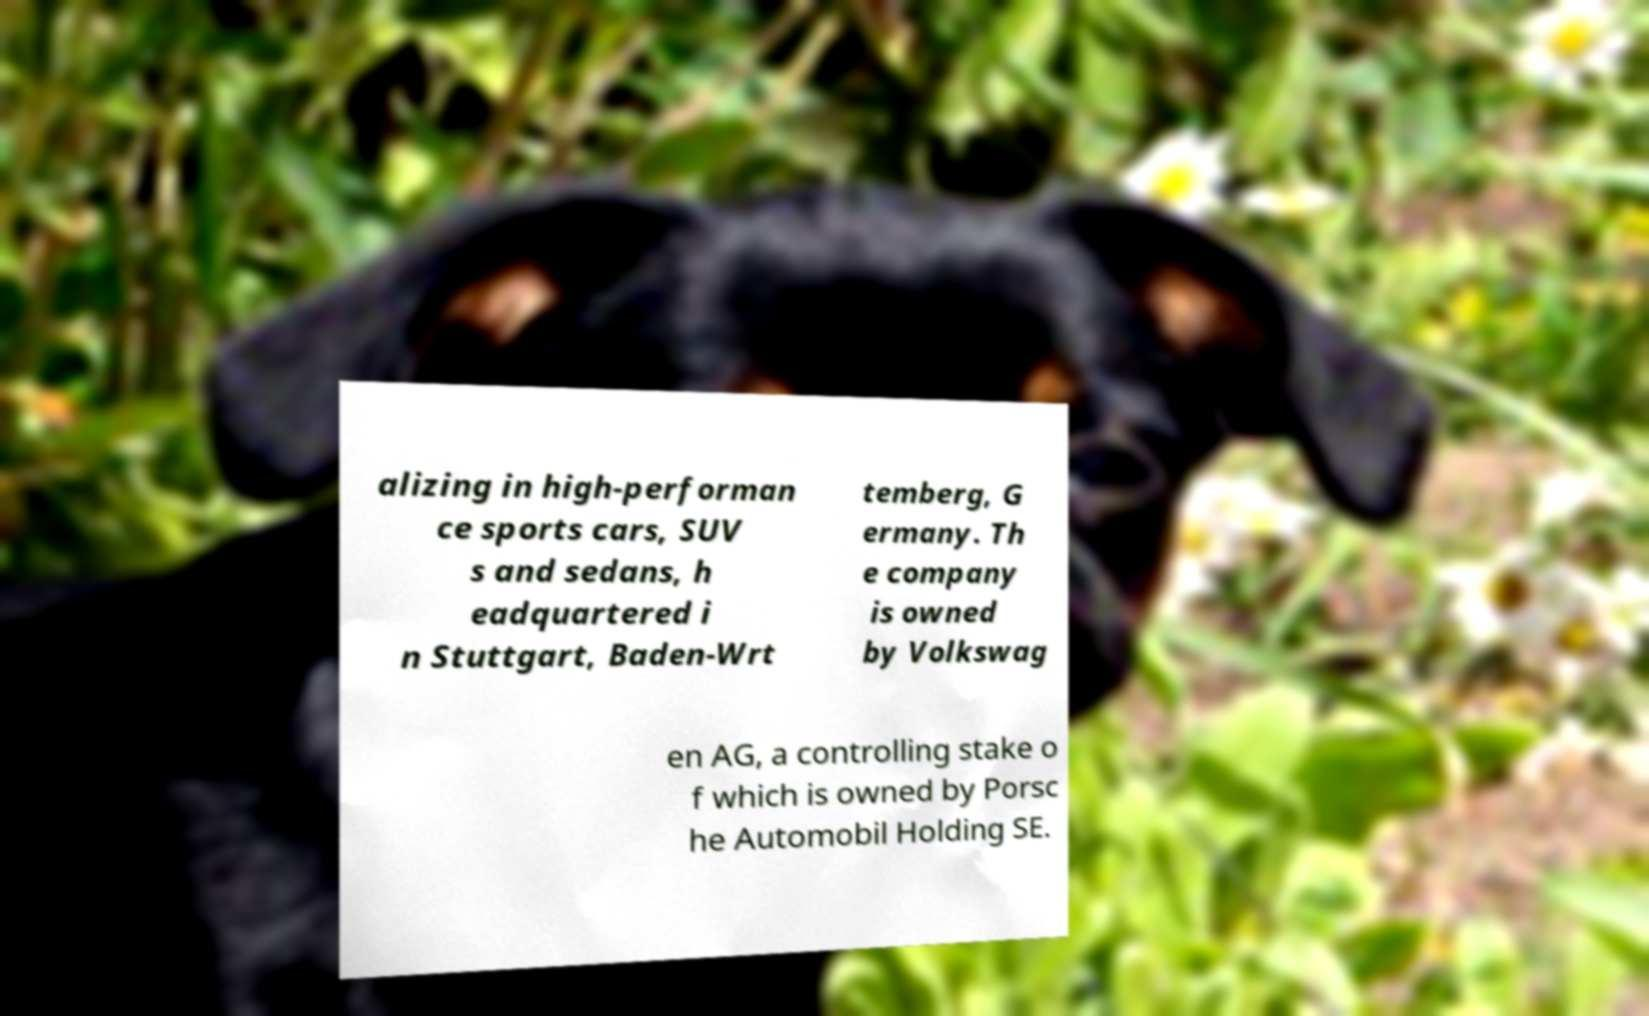Could you extract and type out the text from this image? alizing in high-performan ce sports cars, SUV s and sedans, h eadquartered i n Stuttgart, Baden-Wrt temberg, G ermany. Th e company is owned by Volkswag en AG, a controlling stake o f which is owned by Porsc he Automobil Holding SE. 